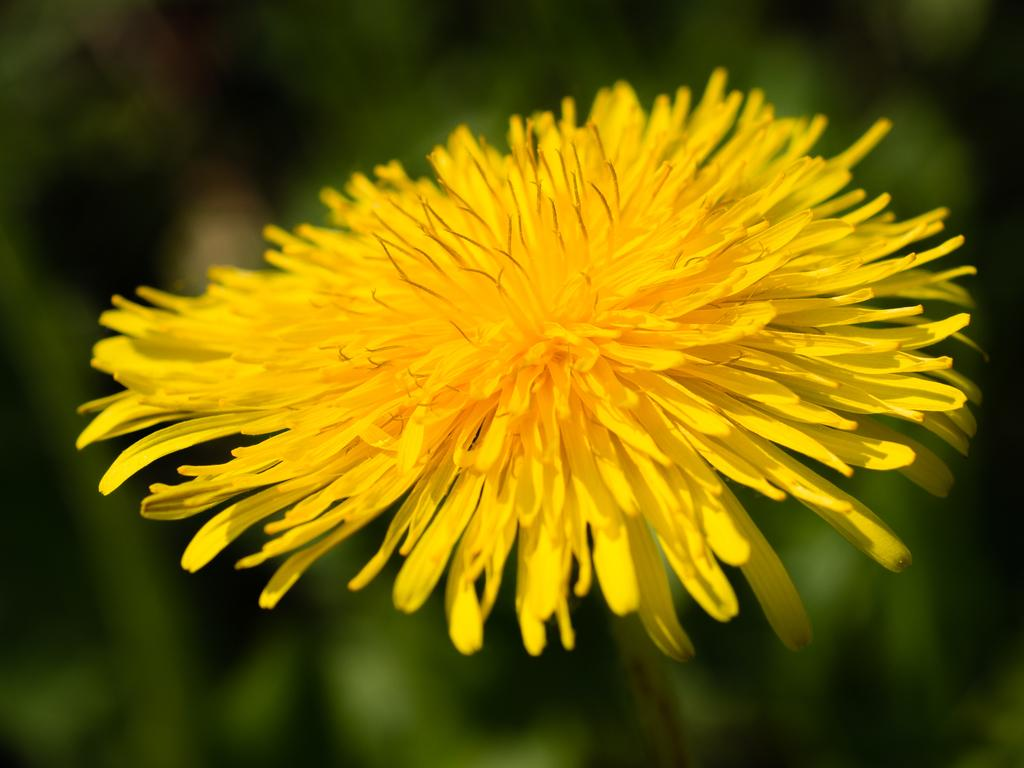What is the main subject of the picture? The main subject of the picture is a flower. How many petals does the flower have? The flower has many petals. What color is the flower? The flower is yellow in color. Can you see any ants crawling on the flower in the image? There is no mention of ants or any other insects in the image, so it cannot be determined if any are present. Is the flower being used for a bath in the image? There is no indication of a bath or any water-related activity in the image; it simply features a yellow flower with many petals. 